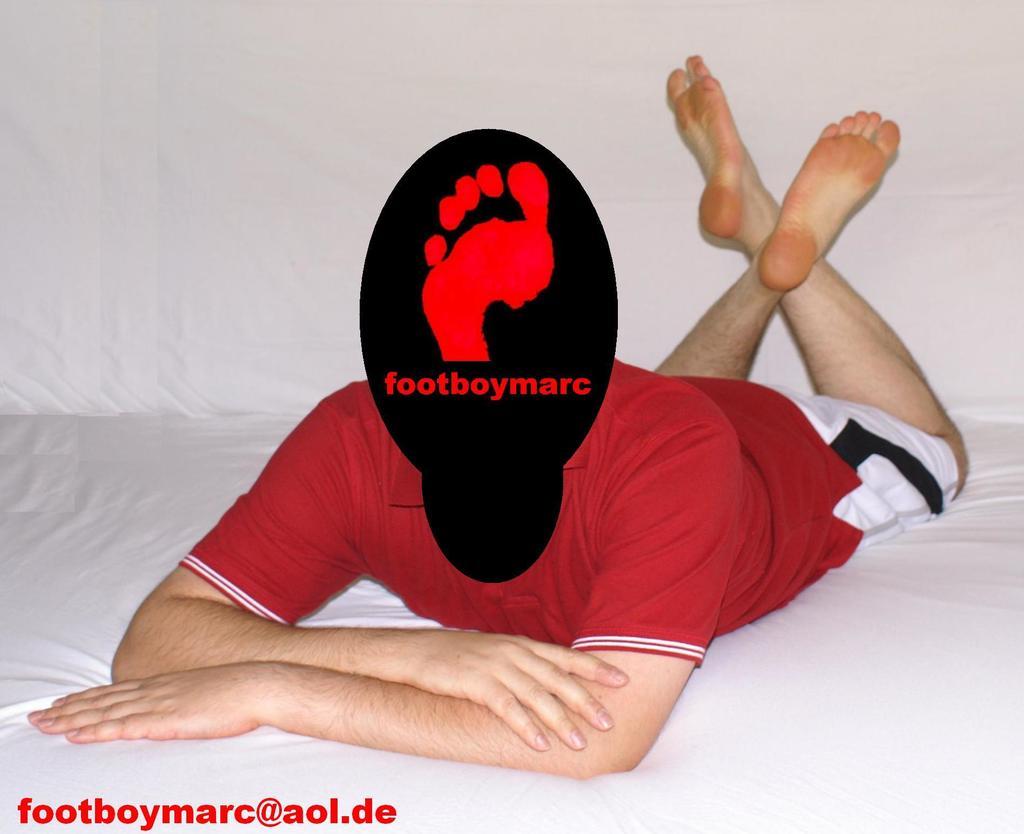What is the name on the hat?
Keep it short and to the point. Footboymarc. What is the email address on the bottom of the picture?
Keep it short and to the point. Footboymarc@aol.de. 